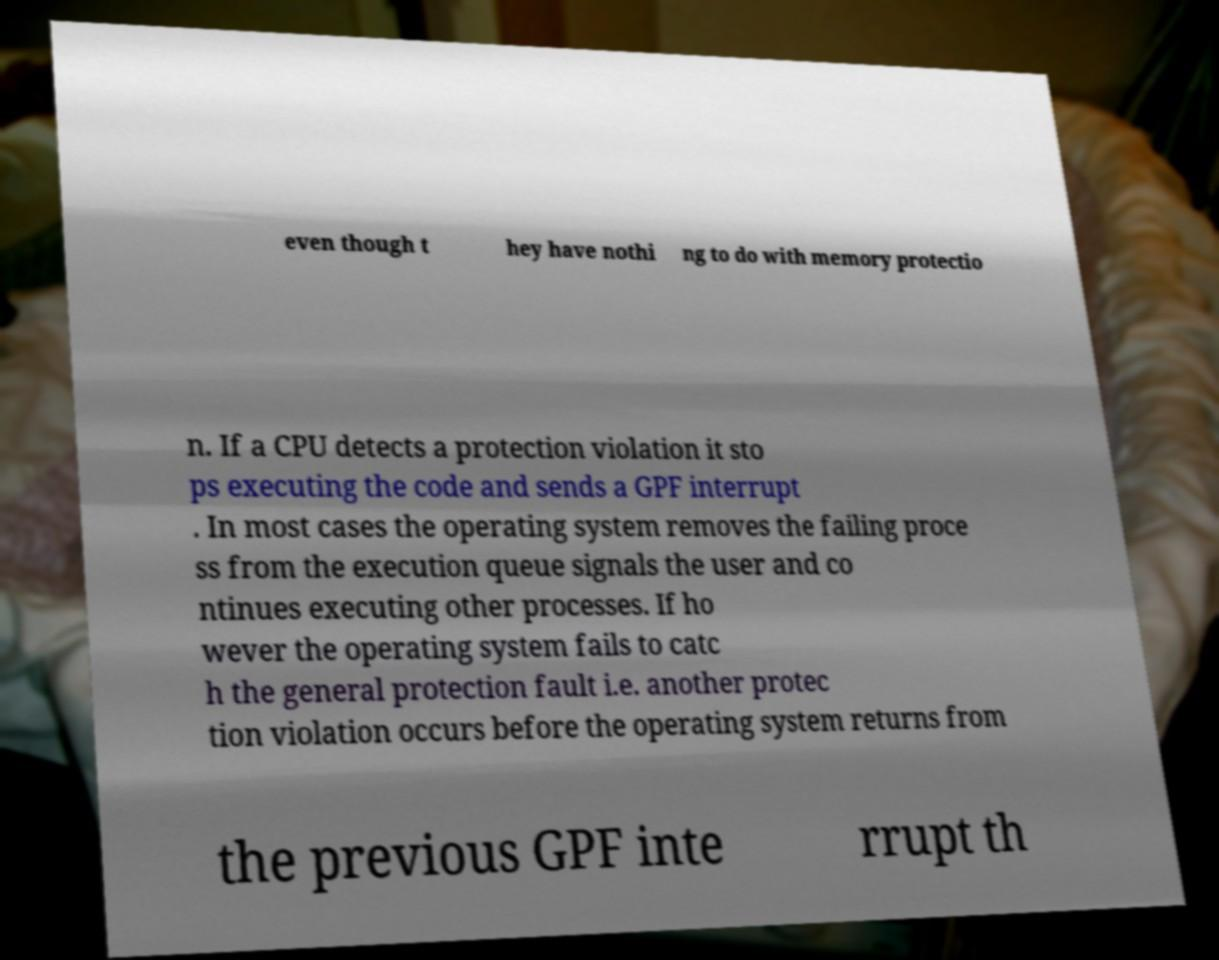For documentation purposes, I need the text within this image transcribed. Could you provide that? even though t hey have nothi ng to do with memory protectio n. If a CPU detects a protection violation it sto ps executing the code and sends a GPF interrupt . In most cases the operating system removes the failing proce ss from the execution queue signals the user and co ntinues executing other processes. If ho wever the operating system fails to catc h the general protection fault i.e. another protec tion violation occurs before the operating system returns from the previous GPF inte rrupt th 